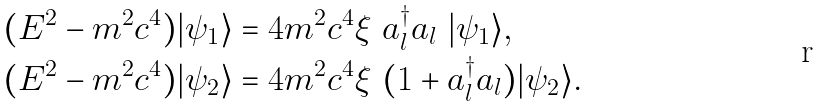<formula> <loc_0><loc_0><loc_500><loc_500>& ( E ^ { 2 } - m ^ { 2 } c ^ { 4 } ) | \psi _ { 1 } \rangle = 4 m ^ { 2 } c ^ { 4 } \xi \ a _ { l } ^ { \dagger } a _ { l } \ | \psi _ { 1 } \rangle , \\ & ( E ^ { 2 } - m ^ { 2 } c ^ { 4 } ) | \psi _ { 2 } \rangle = 4 m ^ { 2 } c ^ { 4 } \xi \ ( 1 + a _ { l } ^ { \dagger } a _ { l } ) | \psi _ { 2 } \rangle . \\</formula> 